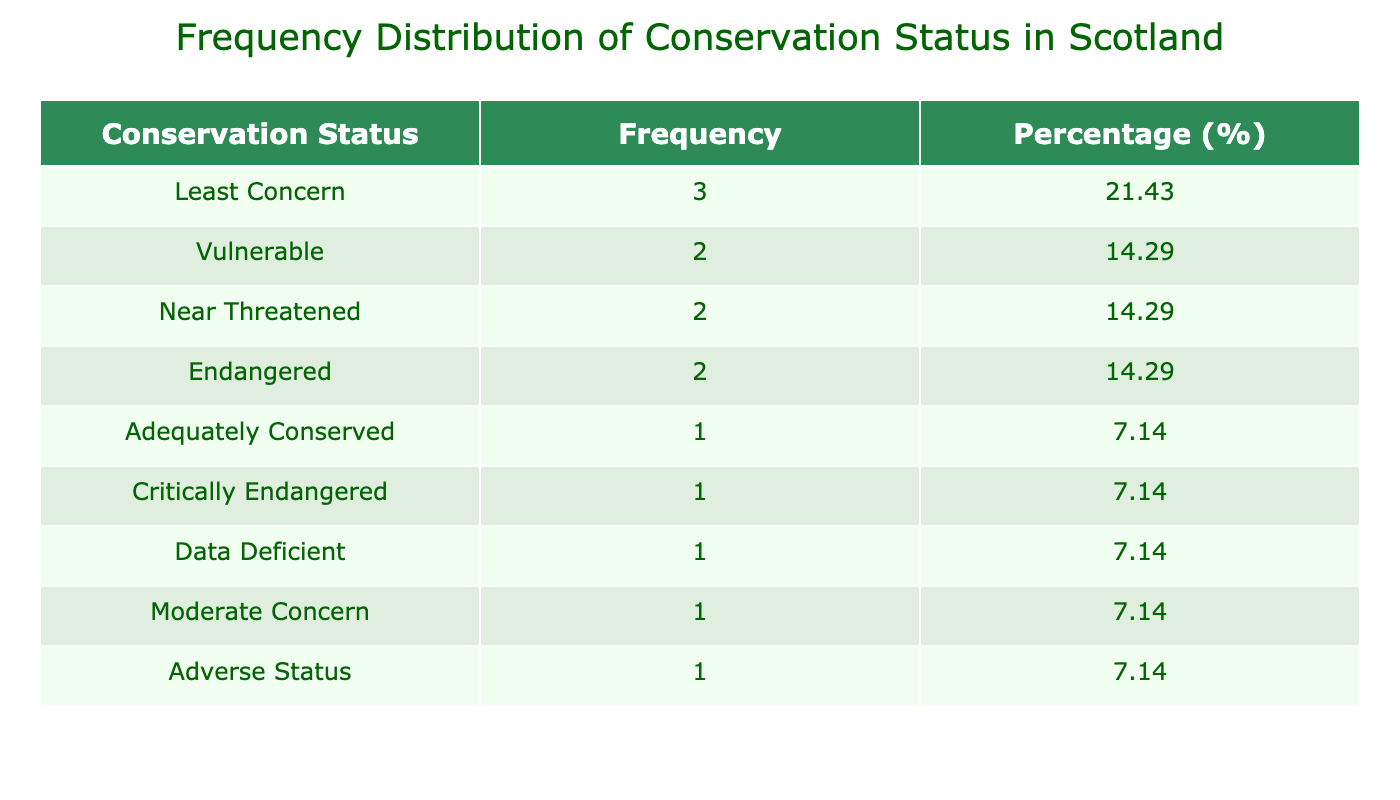What is the frequency of species with a "Vulnerable" conservation status? In the table, there are two species listed with a "Vulnerable" conservation status: "Pedicularis sylvatica" from the Isle of Skye and "Salix herbacea" from the Cairngorms. Therefore, the frequency of species with this status is 2.
Answer: 2 What percentage of species have an "Endangered" conservation status? There are two species with an "Endangered" conservation status: "Orkney Vole" and "Capercaillie". The total number of species in the table is 10. To calculate the percentage, we take (2/10) * 100 = 20%.
Answer: 20% Are there any species classified as "Critically Endangered"? Yes, the table lists "Orkney Mouse-ear" as having a "Critically Endangered" conservation status, indicating that there is at least one species in this category.
Answer: Yes What is the difference in population estimates between "Least Concern" and "Critically Endangered" species? From the table, the population of "Least Concern" species (Erica tetralix, Athyrium filix-femina, and Hippophae rhamnoides) totals 5000 + 7000 + 6000 = 18000. The population of "Critically Endangered" species is just that of "Orkney Mouse-ear", which is 20. Therefore, the difference is 18000 - 20 = 17980.
Answer: 17980 What is the conservation status that has the highest frequency? By examining the frequencies, "Least Concern" appears 3 times, "Adequately Conserved" 1 time, "Vulnerable" 2 times, "Near Threatened" 2 times, "Endangered" 2 times, "Critically Endangered" 1 time, and "Data Deficient" 1 time. Since "Least Concern" is the only one with 3 occurrences, it has the highest frequency.
Answer: Least Concern What is the average population estimate of the species listed as "Near Threatened"? There are two species with the conservation status "Near Threatened": "Scotch Pine Marten" with a population of 300 and "Anacamptis morio" with a population of 300. The average is calculated by (300 + 300) / 2 = 300.
Answer: 300 Is there a species with a "Data Deficient" conservation status among the animals? Yes, "Minke Whale" is listed with a conservation status of "Data Deficient" in the table. This confirms that there is at least one animal species in this category.
Answer: Yes How many species are classified under the conservation status of "Moderate Concern"? There is only one species listed under "Moderate Concern": "Lapwing". Therefore, the count is 1.
Answer: 1 What is the total population estimate of all "Animal" species combined? The total population estimate of animals is calculated by adding together the populations of all animal species listed: 1300 (Golden Eagle) + 300 (Scotch Pine Marten) + 1000 (Orkney Vole) + 150 (Minke Whale) + 200 (Capercaillie) + 1200 (Lapwing) + 850 (Yellowhammer) = 4000.
Answer: 4000 